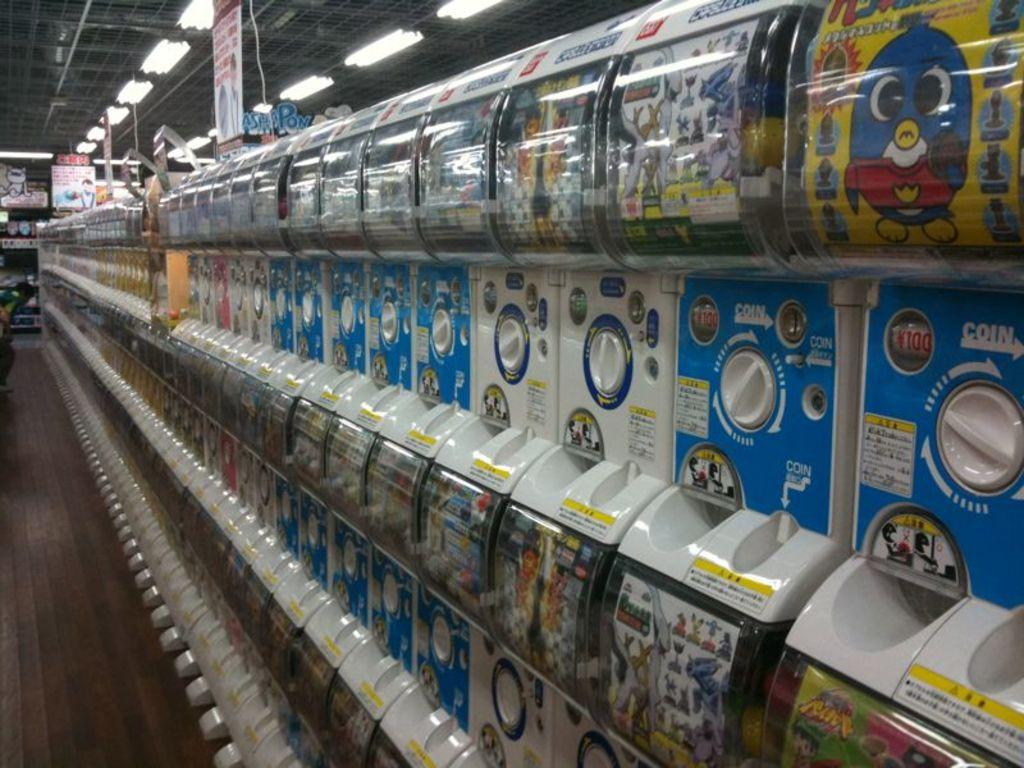<image>
Create a compact narrative representing the image presented. a blue sticker machine that as the word coin on it 